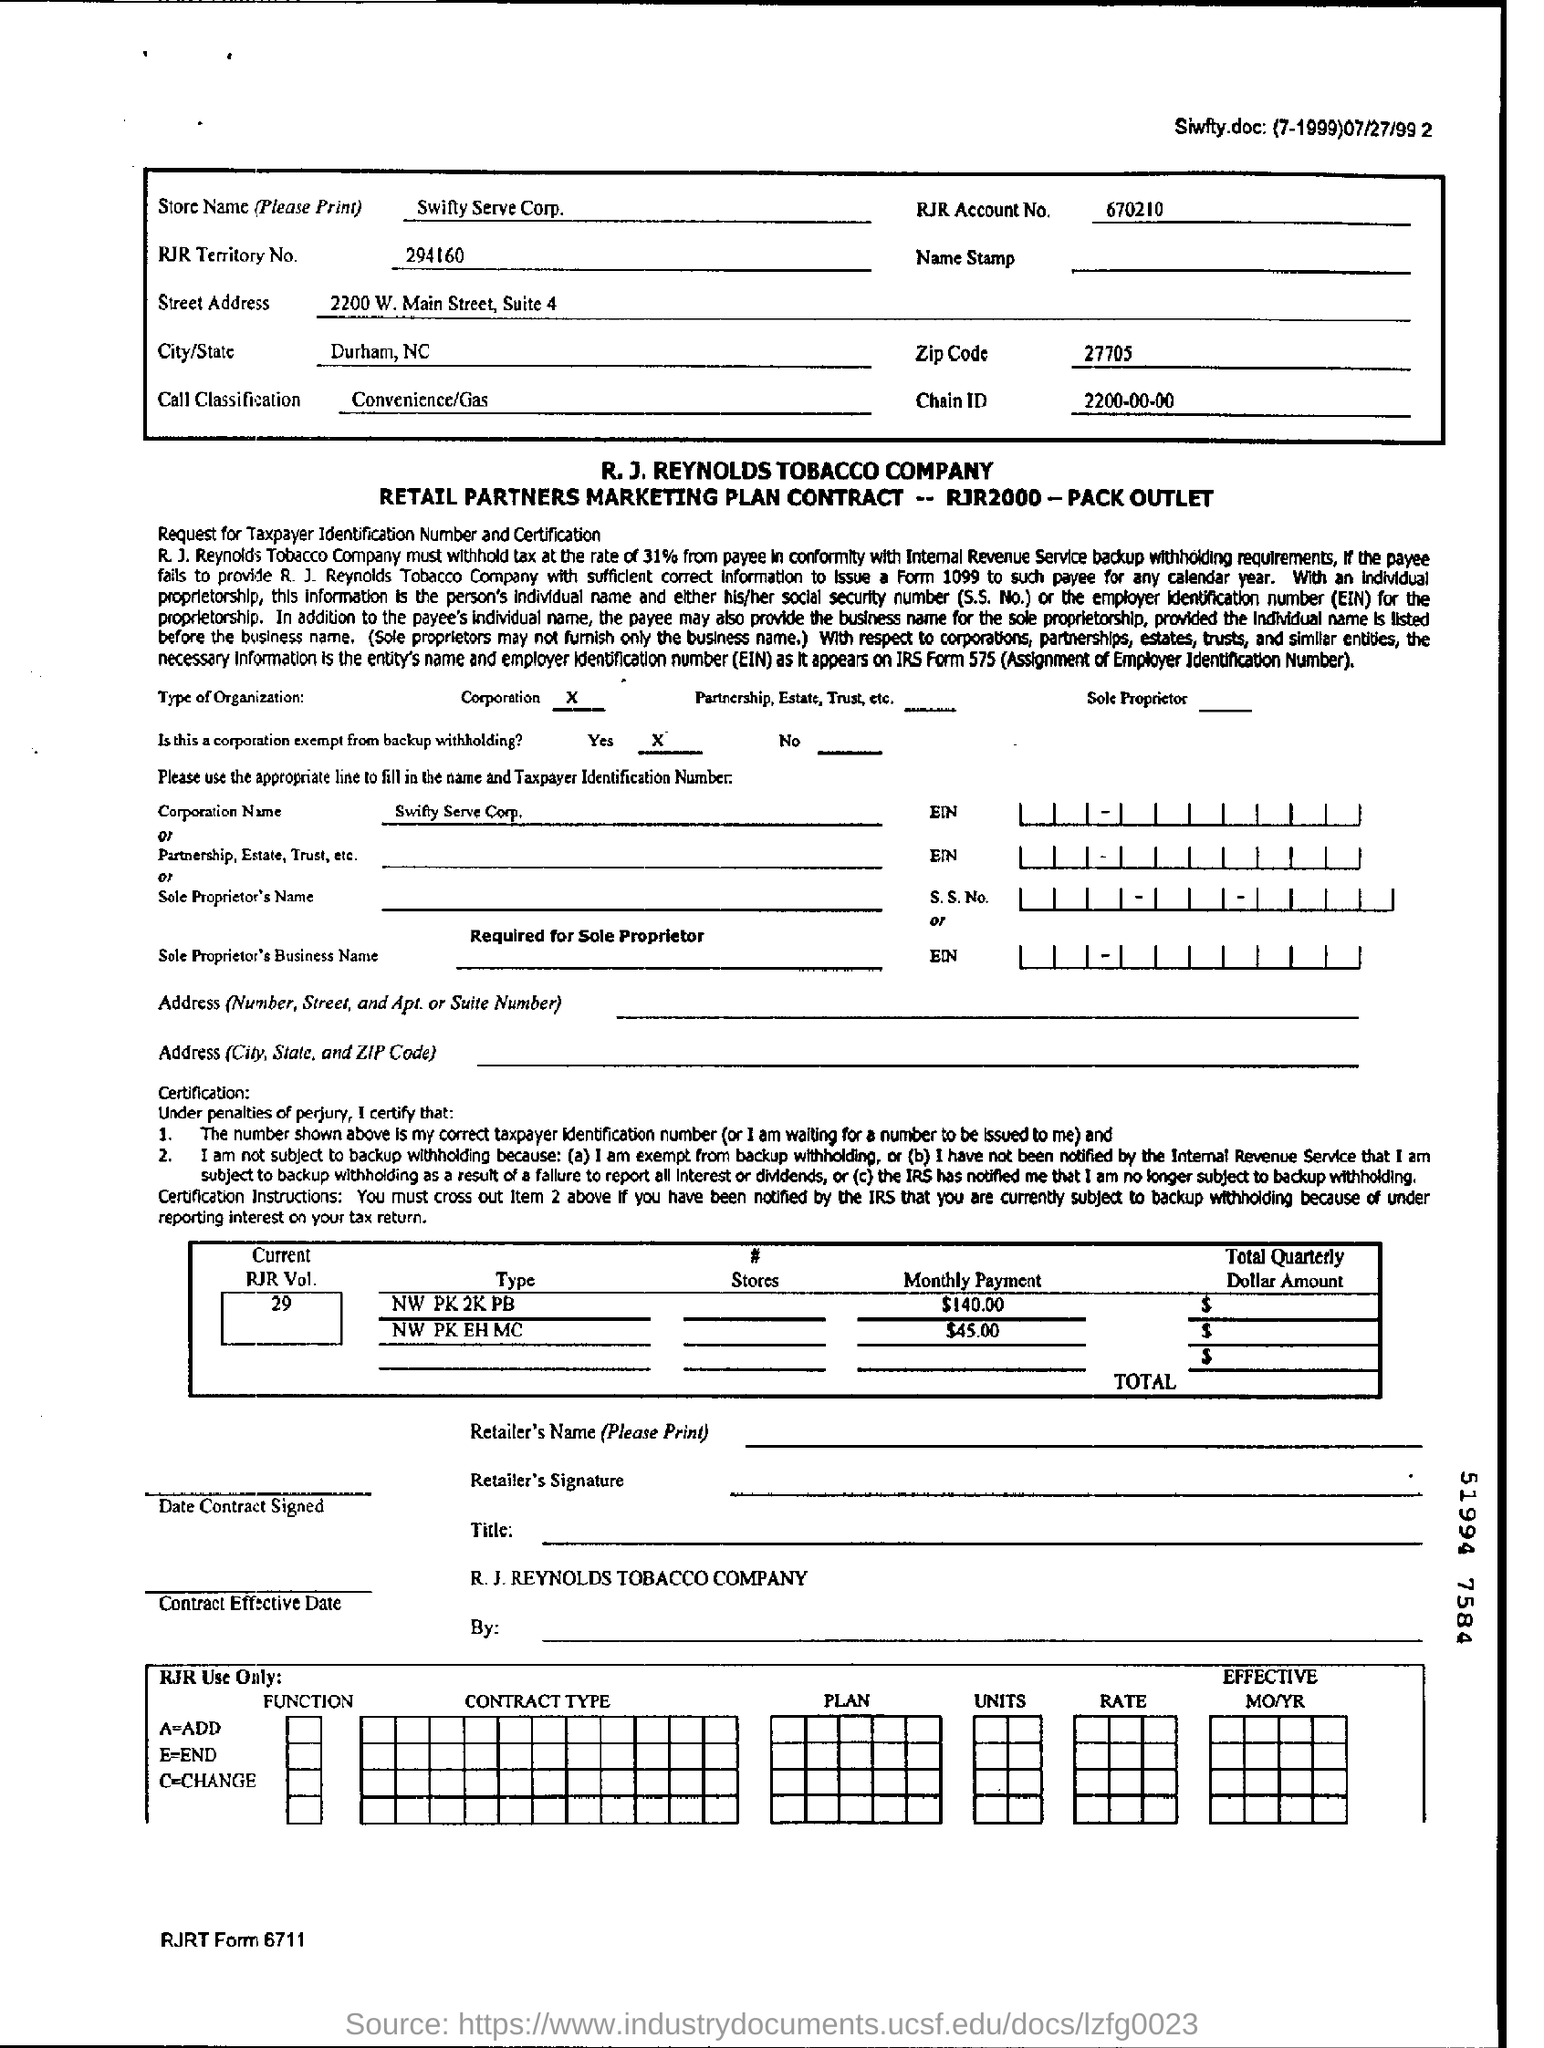Draw attention to some important aspects in this diagram. The RJR Account number is 670210...," the person declared. The chain ID is 2200-00-00, and it is a series of numerical values that identifies a particular chain within a larger system. Swifty Serve Corp is the name of the store. 